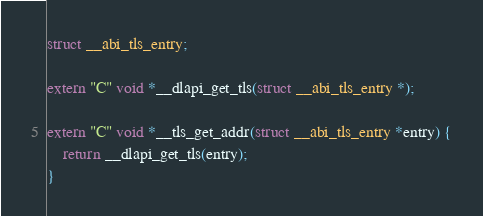Convert code to text. <code><loc_0><loc_0><loc_500><loc_500><_C++_>
struct __abi_tls_entry;

extern "C" void *__dlapi_get_tls(struct __abi_tls_entry *);

extern "C" void *__tls_get_addr(struct __abi_tls_entry *entry) {
	return __dlapi_get_tls(entry);
}

</code> 